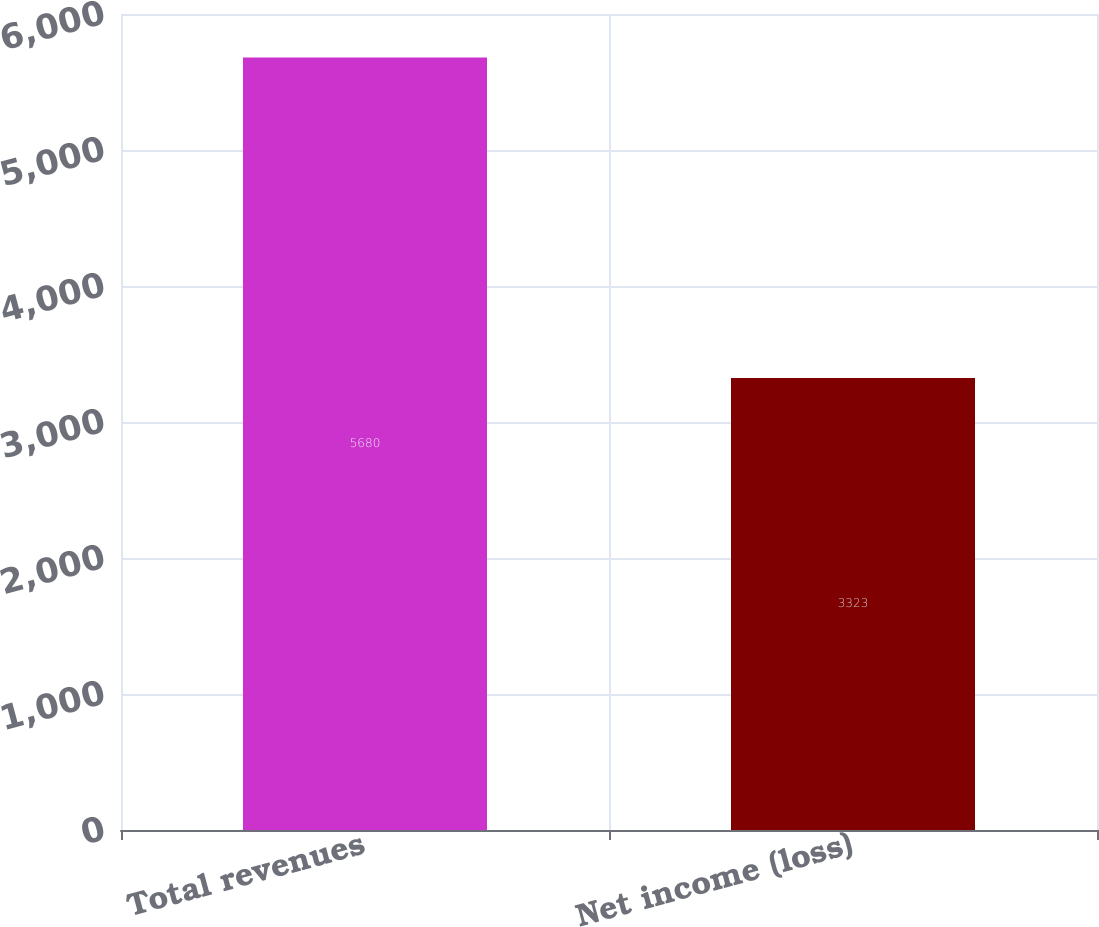<chart> <loc_0><loc_0><loc_500><loc_500><bar_chart><fcel>Total revenues<fcel>Net income (loss)<nl><fcel>5680<fcel>3323<nl></chart> 